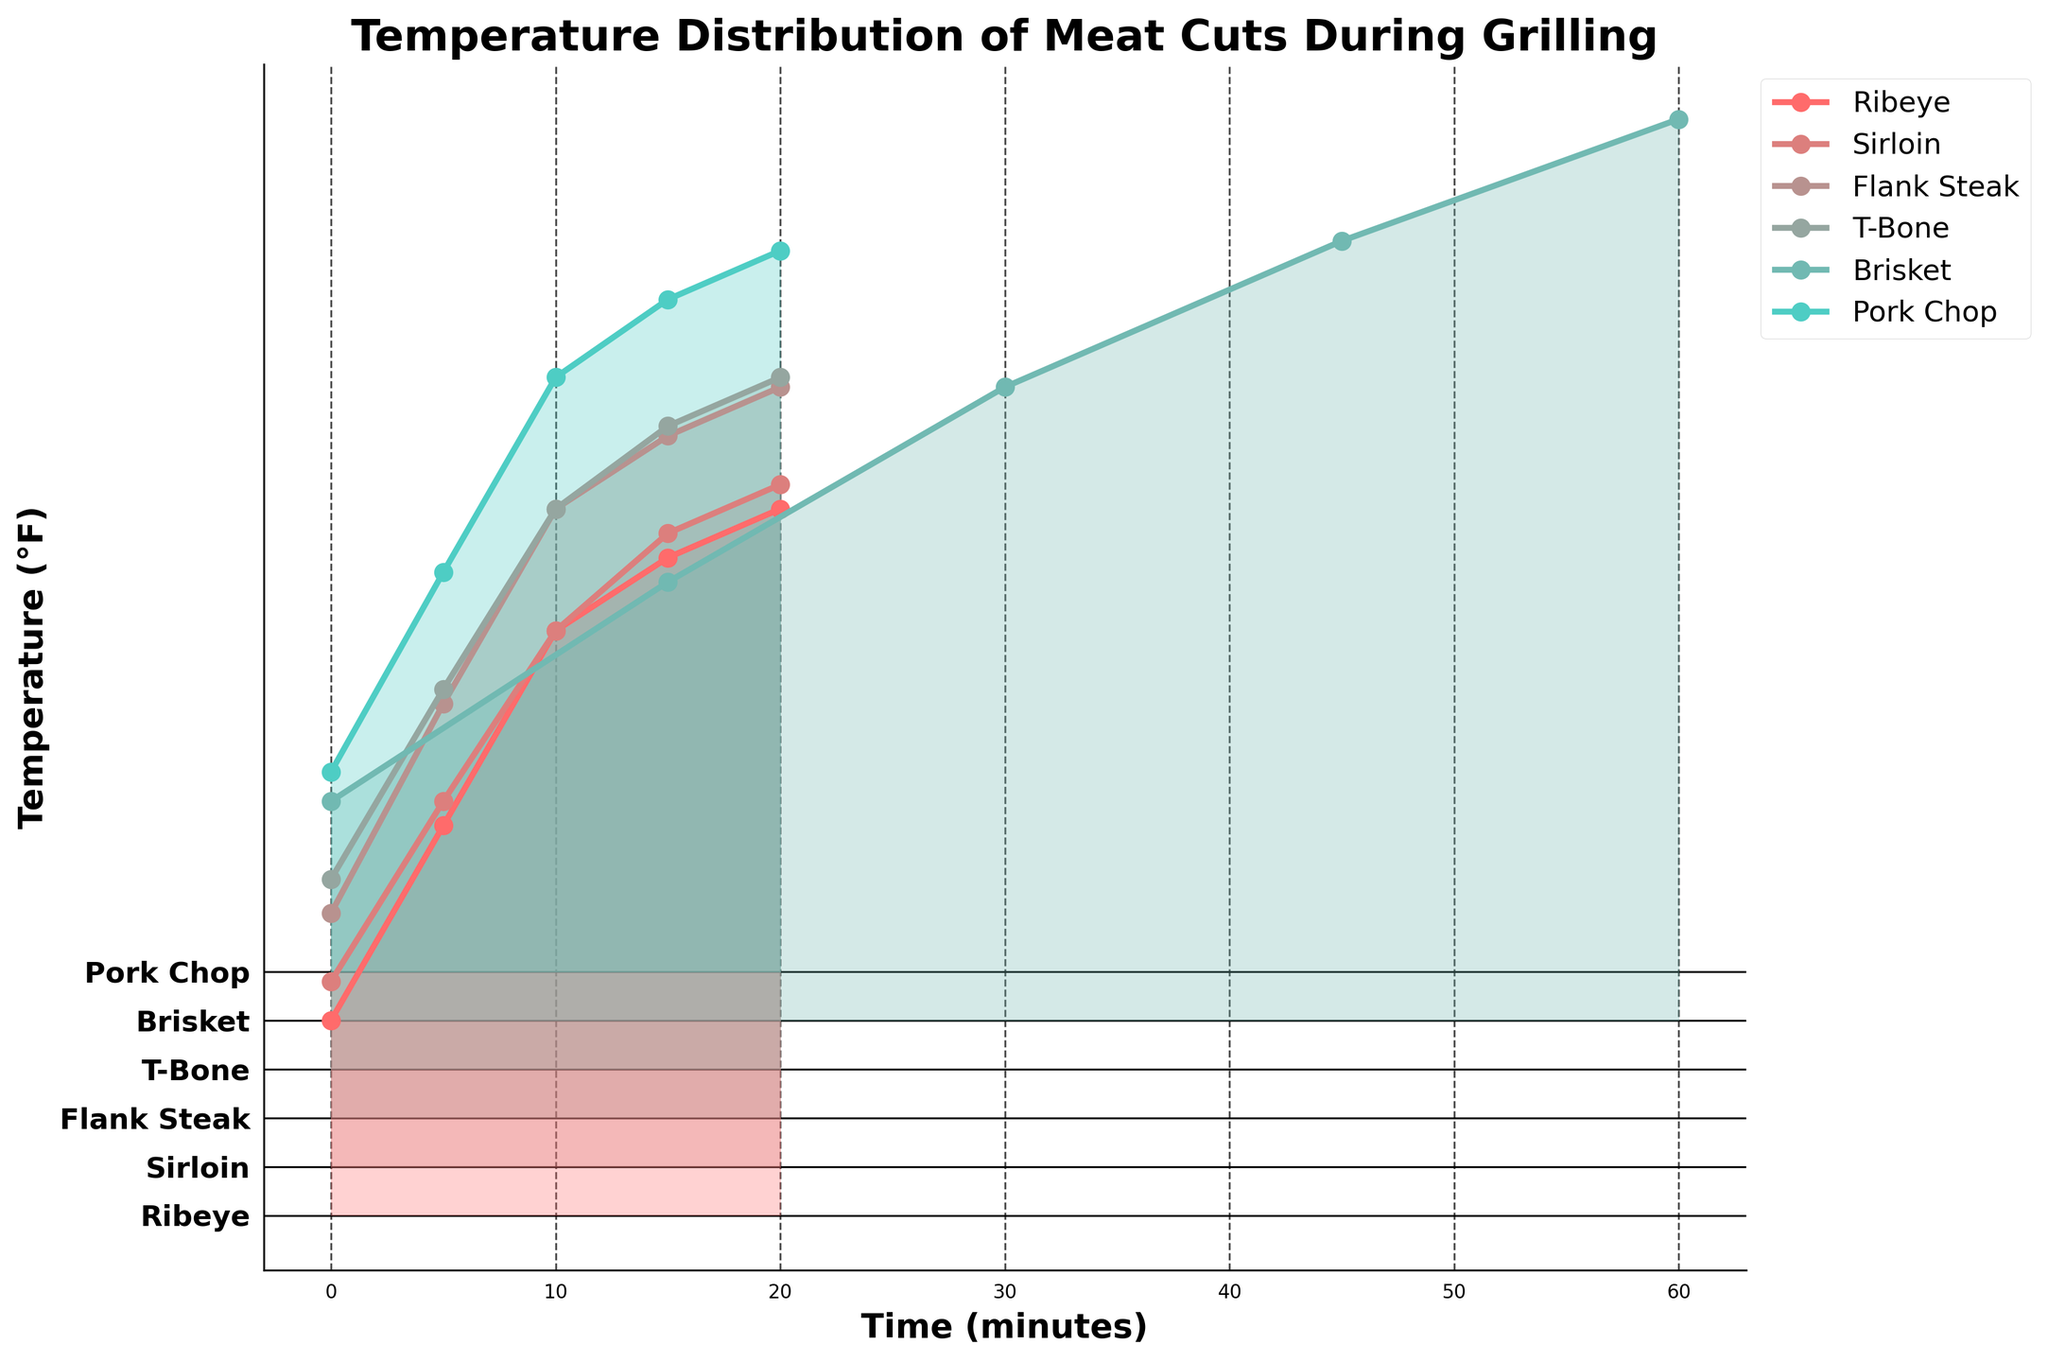Which cut of meat starts with the highest initial temperature? The initial temperatures at time 0 are: Ribeye (40°F), Sirloin (38°F), Flank Steak (42°F), T-Bone (39°F), Brisket (45°F), and Pork Chop (41°F). Brisket is the highest with 45°F.
Answer: Brisket How does the temperature of Ribeye change from 0 to 20 minutes? Ribeye's temperatures recorded at 0, 5, 10, 15, and 20 minutes are 40°F, 80°F, 120°F, 135°F, and 145°F, respectively. Calculate the increase between each point: 40 to 80 (40°F increase), 80 to 120 (40°F), 120 to 135 (15°F), and 135 to 145 (10°F).
Answer: 40-80-120-135-145°F By how much does the temperature of Brisket increase between 15 minutes and 60 minutes? The temperatures at 15 and 60 minutes for Brisket are 90°F and 185°F. Calculate the difference: 185°F - 90°F = 95°F.
Answer: 95°F Which cut reaches the highest temperature at its final recording, and what is that temperature? Checking the final recorded temperatures: Ribeye (145°F), Sirloin (140°F), Flank Steak (150°F), T-Bone (142°F), Brisket (185°F), Pork Chop (148°F). Brisket reaches 185°F.
Answer: Brisket, 185°F At 10 minutes, which cut of meat has the highest temperature? At 10 minutes, the temperatures are: Ribeye (120°F), Sirloin (110°F), Flank Steak (125°F), T-Bone (115°F), Brisket (not recorded), Pork Chop (122°F). Flank Steak is the highest with 125°F.
Answer: Flank Steak Compare the temperature of Sirloin and Pork Chop at 15 minutes. Which one is higher and by how much? At 15 minutes, Sirloin has a temperature of 130°F, and Pork Chop has a temperature of 138°F. Calculate the difference: 138°F - 130°F = 8°F. Pork Chop is higher by 8°F.
Answer: Pork Chop by 8°F What is the average temperature increase per 5-minute interval for the Ribeye between 0 and 20 minutes? Ribeye temperatures at 0, 5, 10, 15, and 20 minutes are 40°F, 80°F, 120°F, 135°F, and 145°F, respectively. Calculate the increases: (80-40=40), (120-80=40), (135-120=15), (145-135=10). Sum the increases: 40+40+15+10=105. There are 4 intervals, so 105/4=26.25°F.
Answer: 26.25°F What is the temperature of T-Bone at the halfway mark of the recorded time? T-Bone temperatures are recorded at 0, 5, 10, 15, and 20 minutes. The halfway mark is at 10 minutes, where the temperature is 115°F.
Answer: 115°F By how much does the temperature of Flank Steak increase from 5 to 20 minutes? Flank Steak temperatures at 5 and 20 minutes are 85°F and 150°F. Calculate the difference: 150°F - 85°F = 65°F.
Answer: 65°F Does any cut of meat reach the same temperature at any point? Which ones and at what time? Compare recorded temperatures across cuts: Ribeye (145°F at 20 min), Sirloin (140°F at 20 min), Flank Steak (150°F at 20 min), T-Bone (142°F at 20 min), Brisket (no matching), Pork Chop (148°F at 20 min). No matching temperatures at any recorded points.
Answer: None 